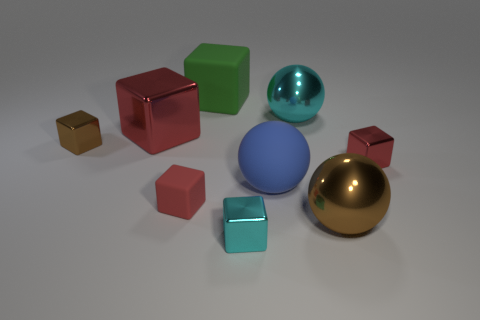Subtract all purple cylinders. How many red cubes are left? 3 Subtract all green matte cubes. How many cubes are left? 5 Subtract all green blocks. How many blocks are left? 5 Subtract 1 cubes. How many cubes are left? 5 Add 1 cubes. How many objects exist? 10 Subtract all gray cubes. Subtract all brown spheres. How many cubes are left? 6 Subtract all blocks. How many objects are left? 3 Add 5 rubber cubes. How many rubber cubes exist? 7 Subtract 0 yellow cubes. How many objects are left? 9 Subtract all brown metal blocks. Subtract all small purple cylinders. How many objects are left? 8 